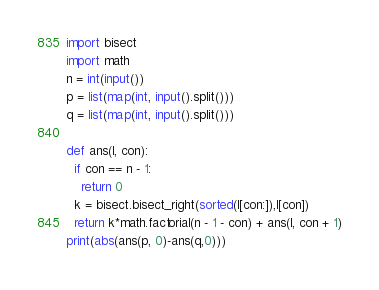Convert code to text. <code><loc_0><loc_0><loc_500><loc_500><_Python_>import bisect
import math
n = int(input())
p = list(map(int, input().split()))
q = list(map(int, input().split()))

def ans(l, con):
  if con == n - 1:
    return 0
  k = bisect.bisect_right(sorted(l[con:]),l[con])
  return k*math.factorial(n - 1 - con) + ans(l, con + 1)
print(abs(ans(p, 0)-ans(q,0)))</code> 